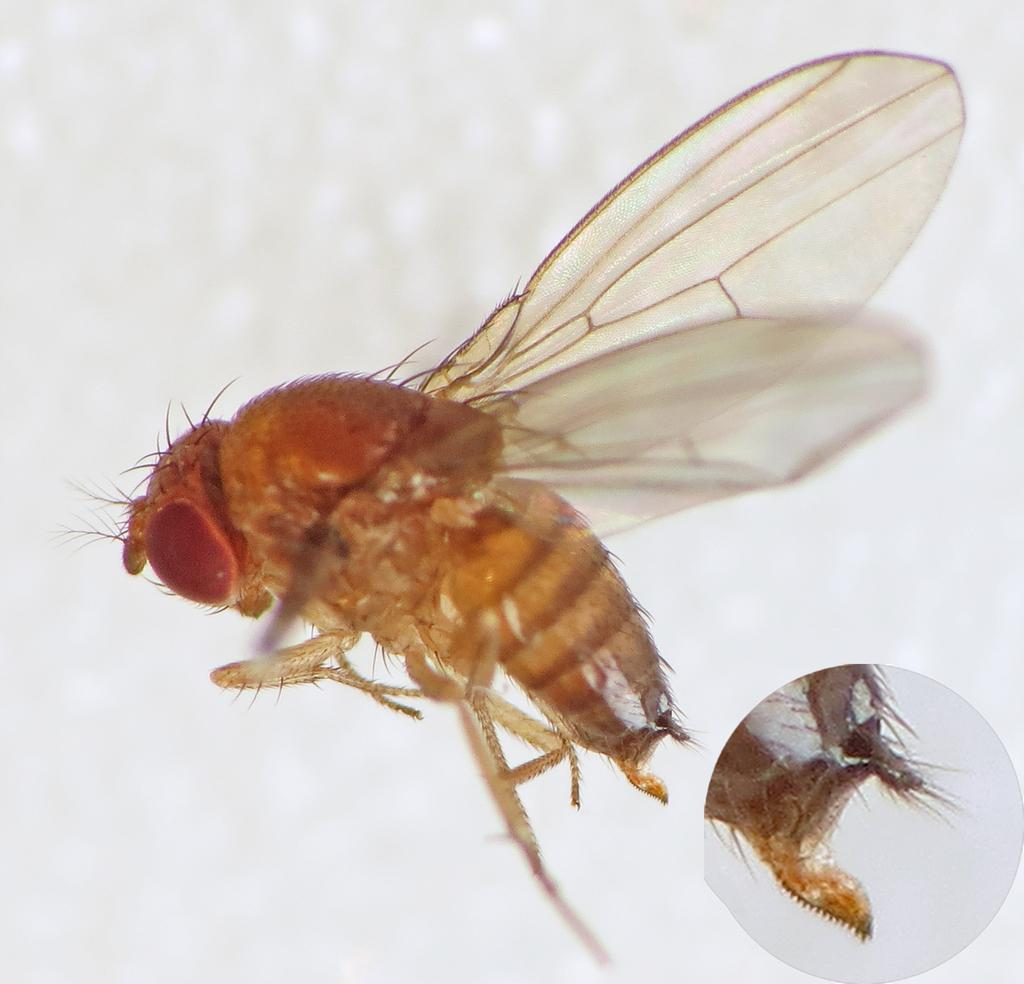What is the main subject of the image? There is an insect in the image. What is the color of the background in the image? The insect is on a white background. Where is the back part of the insect located in the image? The back part of the insect is visible in the bottom right of the image. What time of day is depicted in the image? The image does not show a specific time of day, as it only features an insect on a white background. Can you tell me how many toads are present in the image? There are no toads present in the image; it only features an insect. 